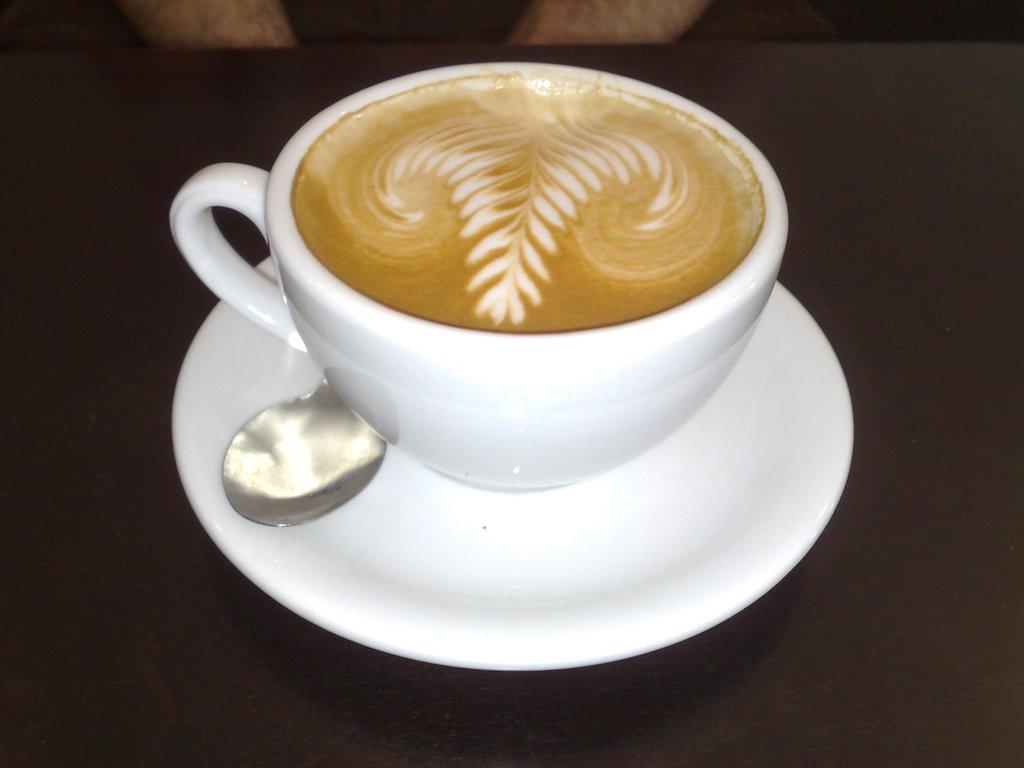What is located at the bottom of the image? There is a table at the bottom of the image. What objects are on the table? There is a saucer, a cup, and a spoon on the table. Who is present in the image? A person is sitting behind the table. What type of slope can be seen in the image? There is no slope present in the image. What is the person using to perform calculations in the image? There is no calculator present in the image, and the person's activity is not mentioned. 